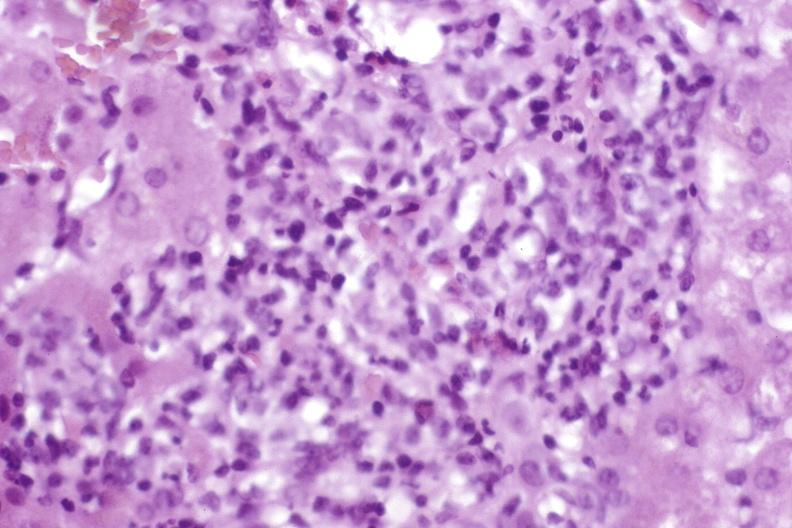does this image show moderate acute rejection?
Answer the question using a single word or phrase. Yes 